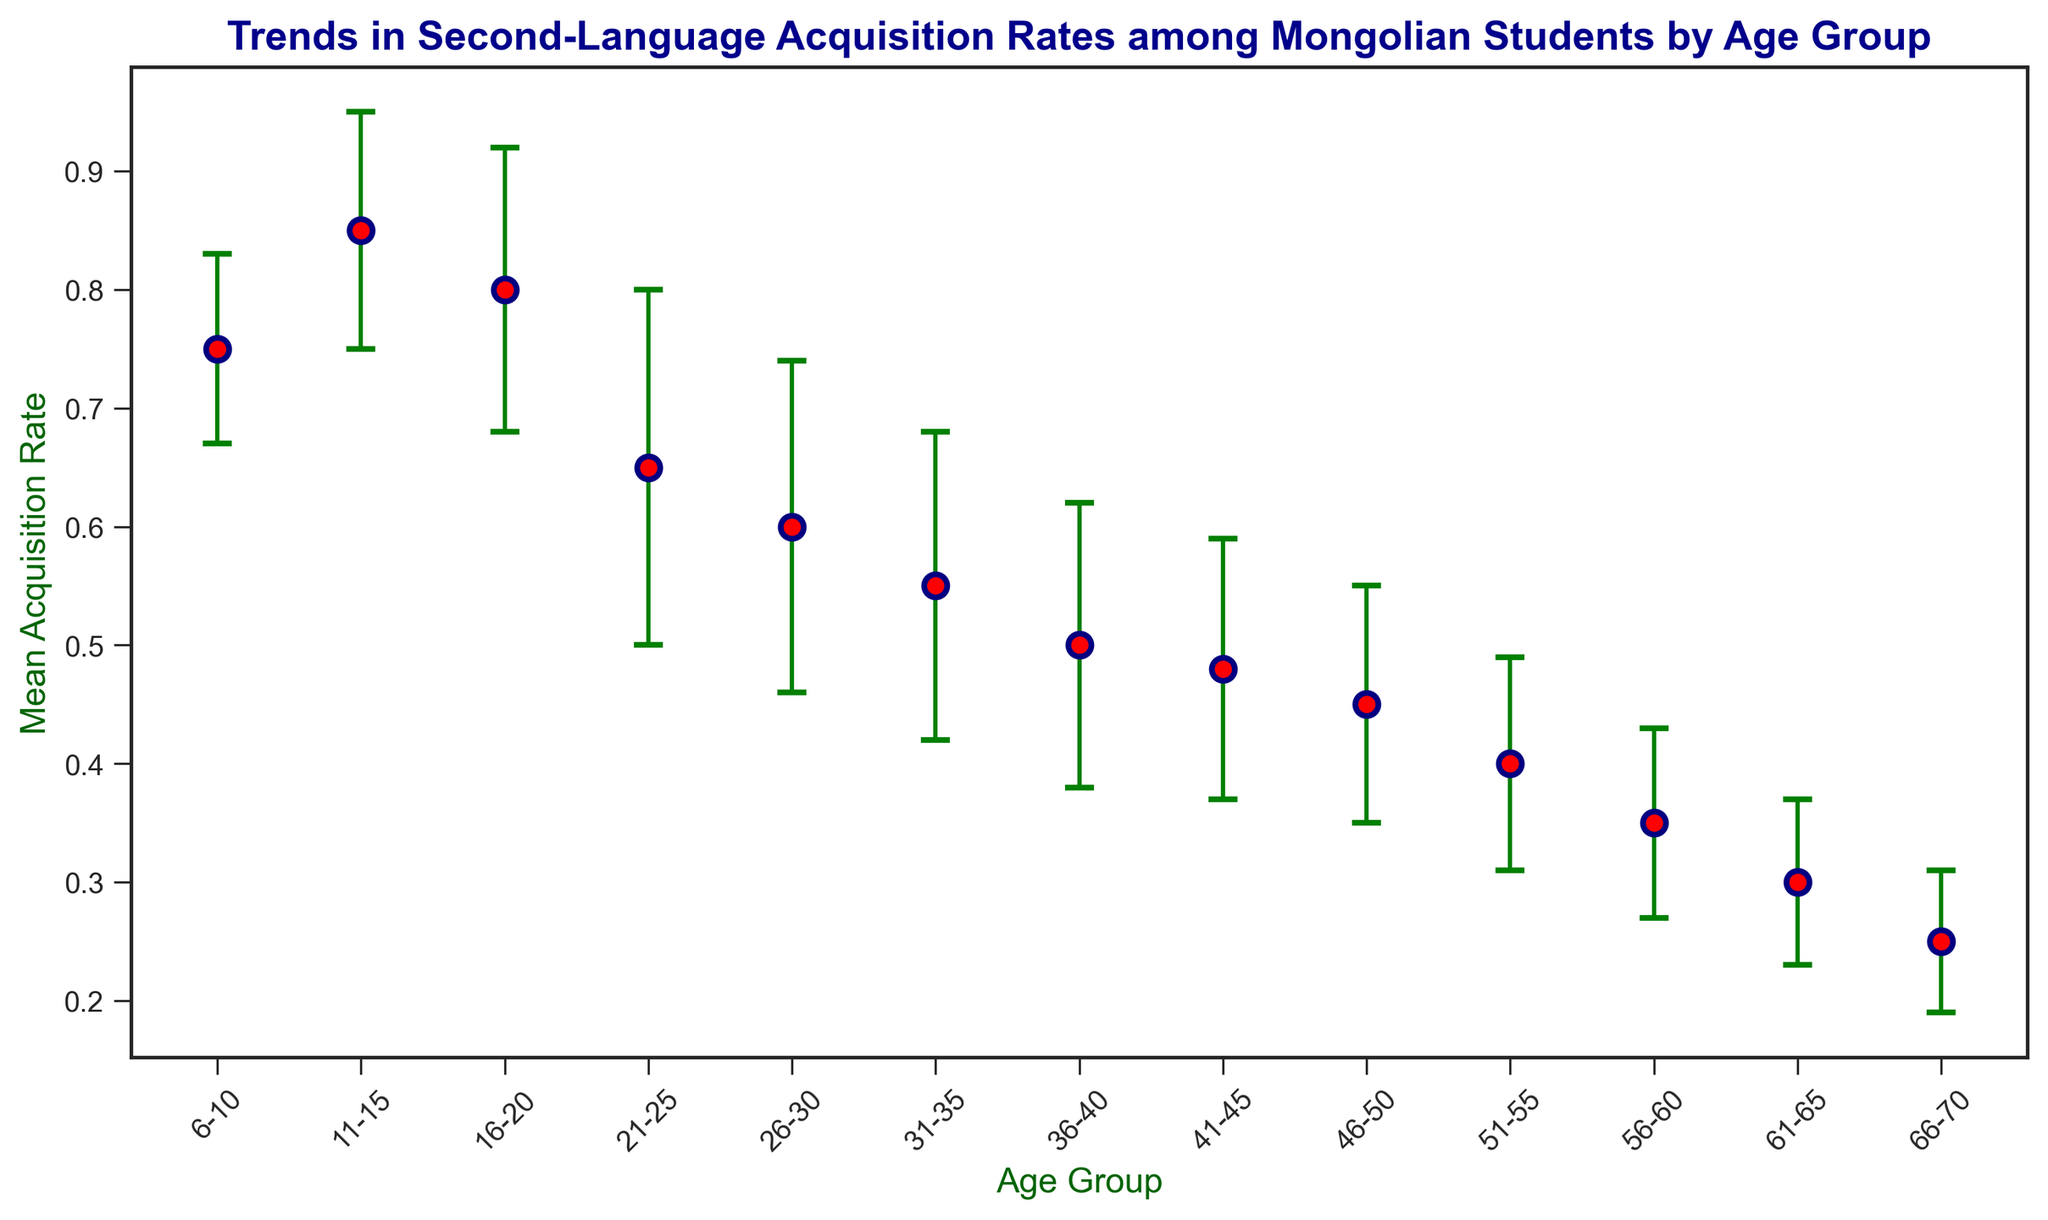What's the age group with the highest mean acquisition rate? Look at the y-axis representing the mean acquisition rates and identify the tallest red marker. The tallest marker corresponds to the age group 11-15.
Answer: 11-15 What's the difference in mean acquisition rates between the age groups 6-10 and 66-70? Find the mean acquisition rates for these groups: 6-10 has a rate of 0.75 and 66-70 has a rate of 0.25. Compute the difference: 0.75 - 0.25 = 0.50.
Answer: 0.50 Which age group has the largest standard deviation, and what is it? Examine the error bars that represent standard deviations and find the longest one. The age group 21-25 has the longest error bar with a standard deviation of 0.15.
Answer: 21-25, 0.15 How does the mean acquisition rate trend change from age group 16-20 to age group 21-25? Observe the drop in the red markers from age group 16-20 (0.80) to 21-25 (0.65). This indicates a decrease.
Answer: Decrease For the age group 36-40, what is the range of acquisition rates considering the standard deviation? The mean acquisition rate for 36-40 is 0.50. The standard deviation is 0.12. The range is calculated by adding and subtracting the standard deviation from the mean: (0.50 - 0.12) to (0.50 + 0.12), which gives 0.38 to 0.62.
Answer: 0.38 to 0.62 Which age group has the smallest difference between the mean acquisition rate and the standard deviation? Calculate the difference for each age group and identify the smallest one. For example, for 26-30, the difference is 0.60 - 0.14 = 0.46 and so on for each until you find that 66-70 has the smallest difference: 0.25 - 0.06 = 0.19.
Answer: 66-70 What is the overall trend in mean acquisition rate as age increases? Observe the general pattern of the red markers. They tend to decrease as the age groups progress from younger to older.
Answer: Decreasing Which two age groups have the closest mean acquisition rates, and what are these rates? Compare the rates of all consecutive age groups to find the smallest difference. Age groups 41-45 and 46-50 have rates of 0.48 and 0.45, respectively, a difference of only 0.03.
Answer: 41-45 and 46-50, 0.48 and 0.45 What's the average mean acquisition rate for age groups from 16-20 to 31-35? Sum the mean acquisition rates for these four groups: 0.80, 0.65, 0.60, 0.55. Then, divide by 4. (0.80 + 0.65 + 0.60 + 0.55) / 4 = 0.65.
Answer: 0.65 What is the visual representation of uncertainty in the figure? The error bars in the figure provide a visual representation of the standard deviations, indicating the uncertainty around each mean acquisition rate.
Answer: Error bars 